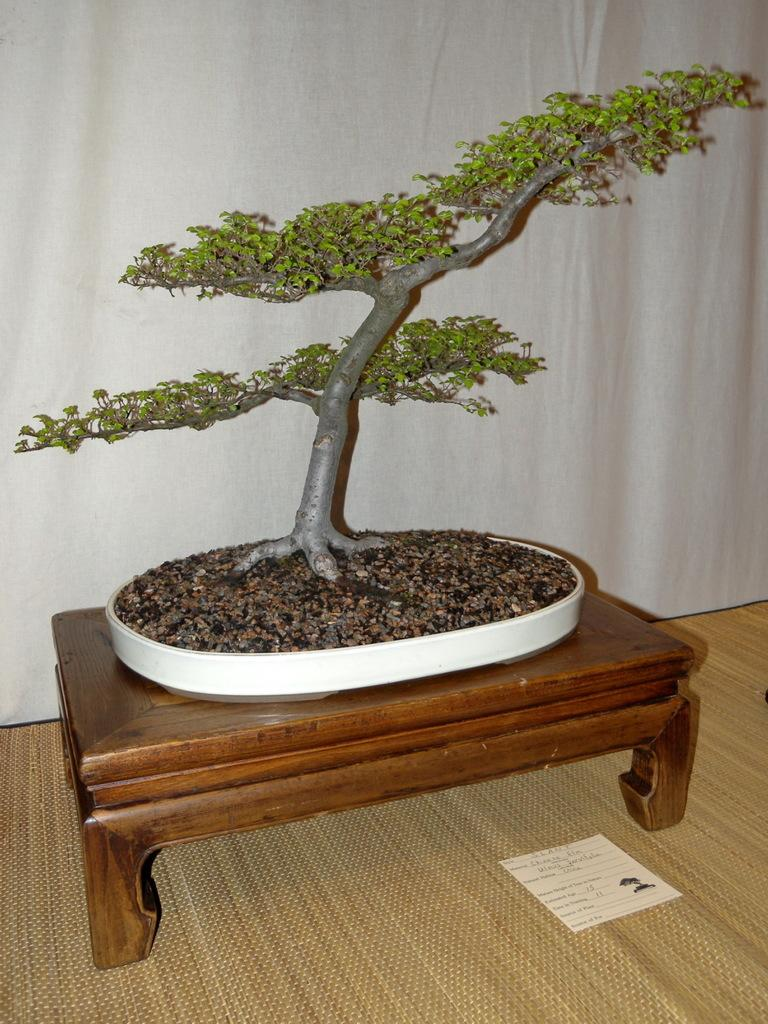What type of plants are in the image? There are trees in a pot in the image. Where is the pot with the trees located? The pot is on a table in the image. What color is the background of the image? The background of the image is white. What riddle can be solved by looking at the image? There is no riddle present in the image; it simply features trees in a pot on a table with a white background. What can be heard in the image? There is no sound or audio present in the image, as it is a static visual representation. 